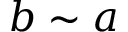<formula> <loc_0><loc_0><loc_500><loc_500>b \sim a</formula> 